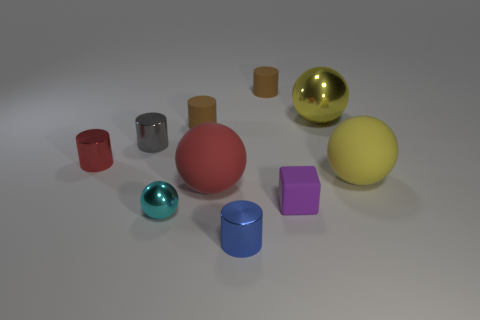The small red thing is what shape?
Your response must be concise. Cylinder. Is the number of cyan balls that are in front of the gray object greater than the number of large yellow objects in front of the tiny cube?
Your response must be concise. Yes. Do the large matte thing on the right side of the big red matte thing and the sphere behind the small red shiny cylinder have the same color?
Offer a terse response. Yes. What is the shape of the yellow metallic object that is the same size as the yellow matte thing?
Keep it short and to the point. Sphere. Are there any other metallic objects that have the same shape as the big shiny thing?
Your answer should be very brief. Yes. Is the ball that is on the left side of the red sphere made of the same material as the red thing that is in front of the red metal cylinder?
Keep it short and to the point. No. The big rubber object that is the same color as the large shiny thing is what shape?
Provide a short and direct response. Sphere. What number of tiny purple cubes are the same material as the large red ball?
Provide a short and direct response. 1. The large metal object has what color?
Your answer should be compact. Yellow. Is the shape of the blue metallic object on the left side of the big yellow rubber thing the same as the small red thing that is behind the yellow matte sphere?
Your answer should be compact. Yes. 